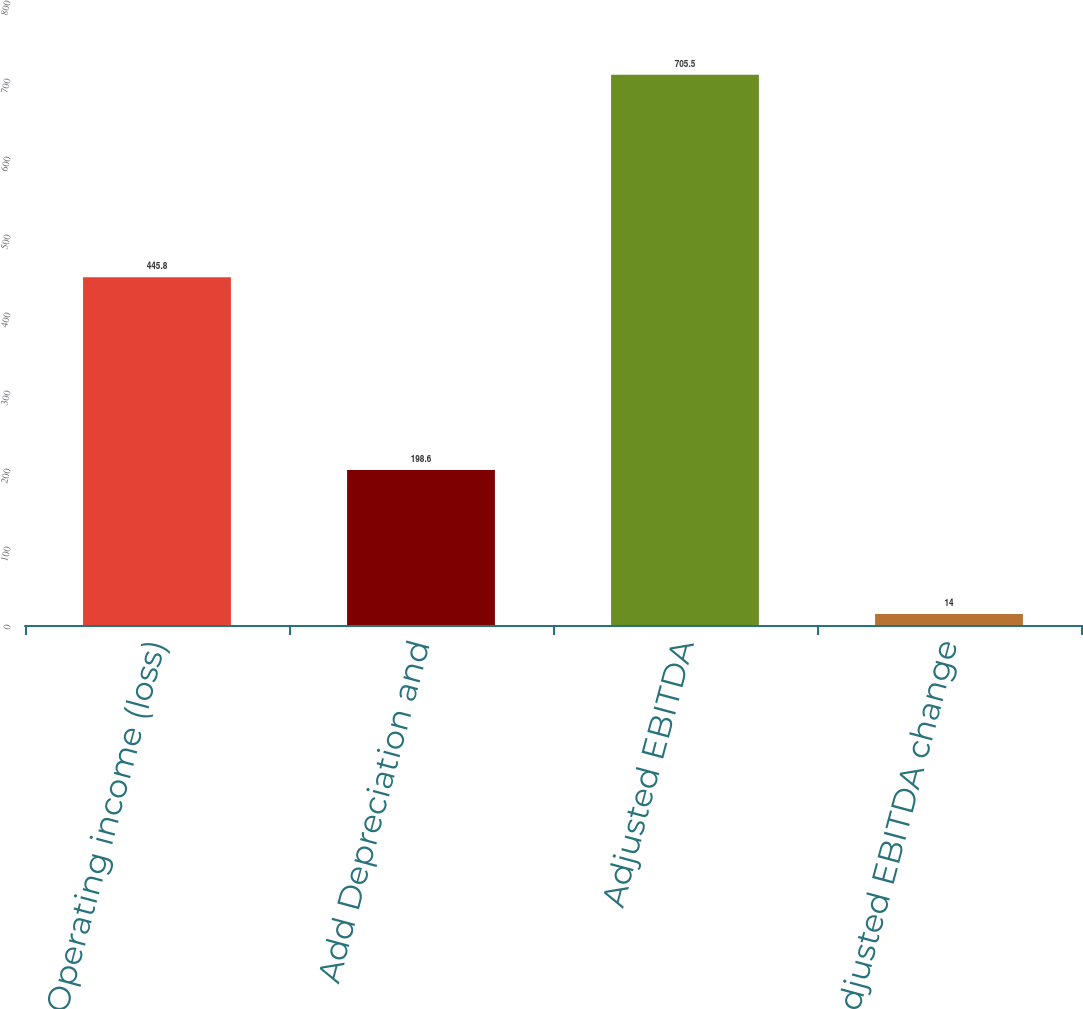<chart> <loc_0><loc_0><loc_500><loc_500><bar_chart><fcel>Operating income (loss)<fcel>Add Depreciation and<fcel>Adjusted EBITDA<fcel>Adjusted EBITDA change<nl><fcel>445.8<fcel>198.6<fcel>705.5<fcel>14<nl></chart> 